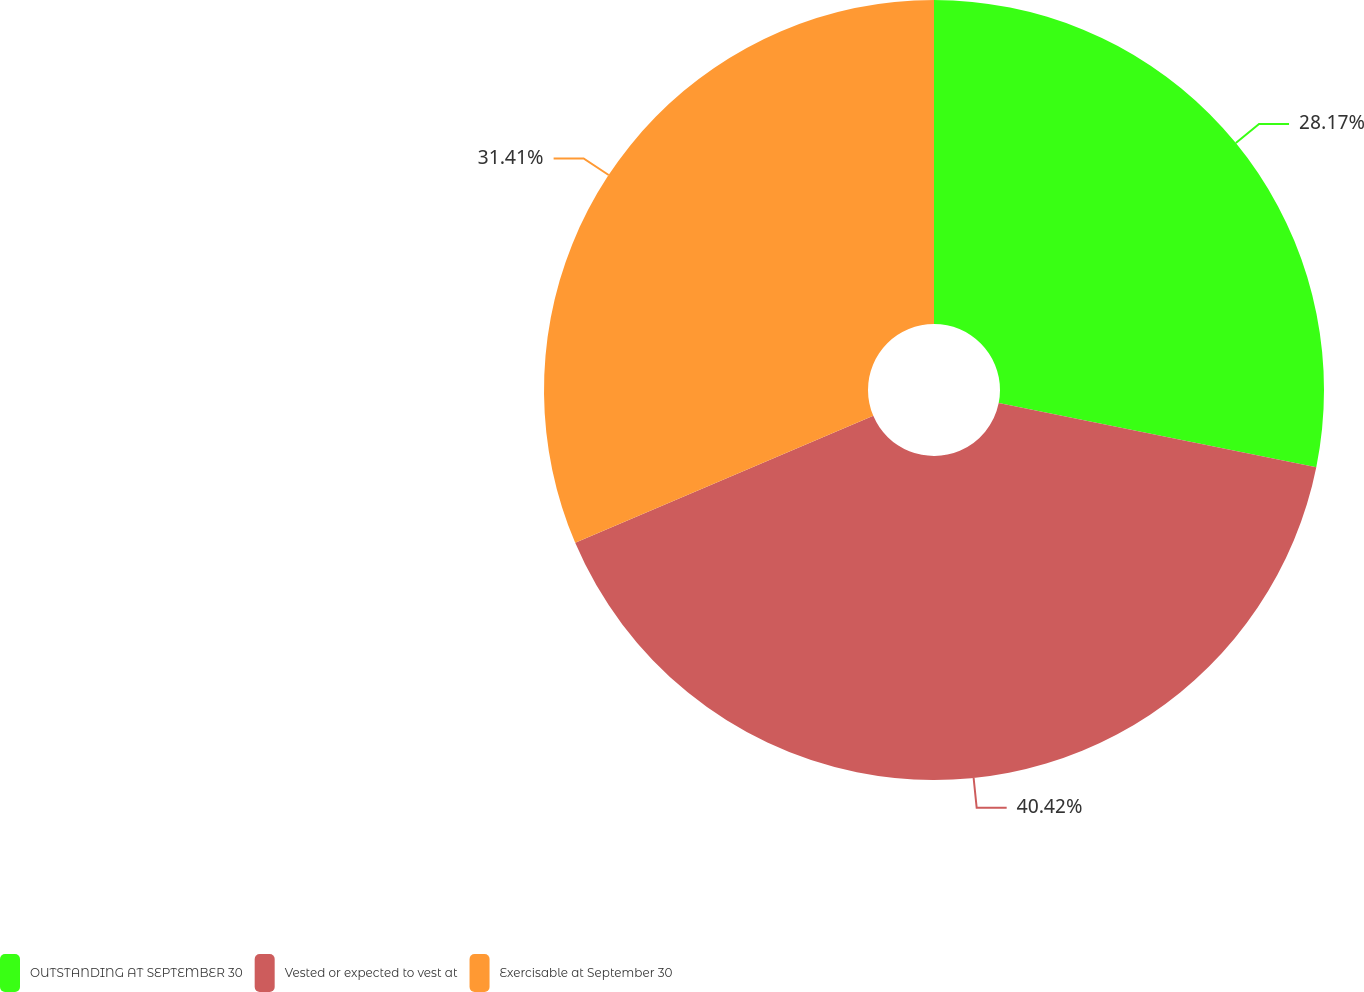Convert chart. <chart><loc_0><loc_0><loc_500><loc_500><pie_chart><fcel>OUTSTANDING AT SEPTEMBER 30<fcel>Vested or expected to vest at<fcel>Exercisable at September 30<nl><fcel>28.17%<fcel>40.42%<fcel>31.41%<nl></chart> 